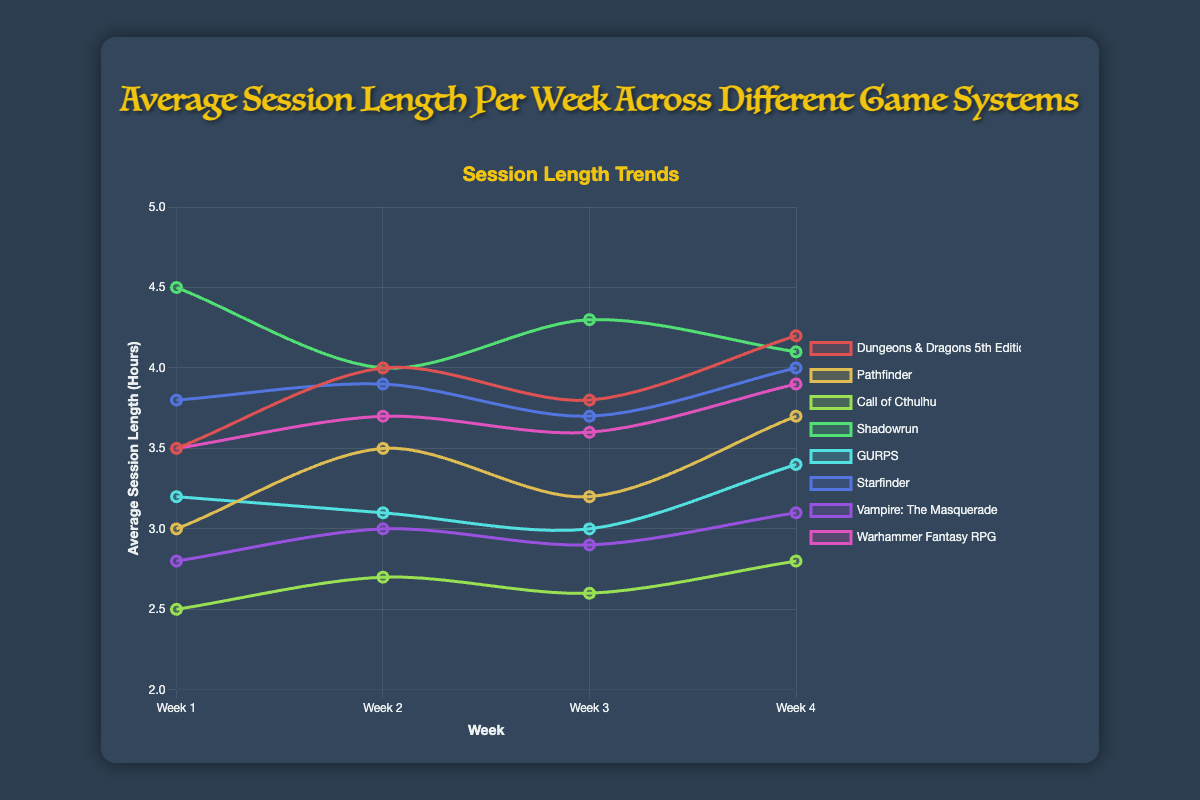What is the average session length per week for Dungeons & Dragons 5th Edition? To find the average, sum the session lengths for the four weeks and divide by 4. (3.5 + 4.0 + 3.8 + 4.2) = 15.5. Divide 15.5 by 4.
Answer: 3.875 Which game system has the highest average session length in Week 1? Compare the session lengths in Week 1 across all systems. The values are: Dungeons & Dragons 5th Edition (3.5), Pathfinder (3.0), Call of Cthulhu (2.5), Shadowrun (4.5), GURPS (3.2), Starfinder (3.8), Vampire: The Masquerade (2.8), Warhammer Fantasy RPG (3.5). Shadowrun has the highest value.
Answer: Shadowrun By how much did the session length for Shadowrun change from Week 1 to Week 4? Subtract the session length in Week 4 from that in Week 1 for Shadowrun. 4.5 (Week 1) - 4.1 (Week 4).
Answer: -0.4 Which game system shows the most consistent session lengths over the four weeks, based on visual inspection? Consistency can be assessed by checking which line is the flattest on the graph. Call of Cthulhu’s line has minor fluctuations between 2.5, 2.7, 2.6, and 2.8.
Answer: Call of Cthulhu What is the total session length for Starfinder over the four weeks? Add the session lengths for each week for Starfinder. 3.8 + 3.9 + 3.7 + 4.0.
Answer: 15.4 Which game systems increased their session lengths from Week 1 to Week 4? Dungeons & Dragons 5th Edition (3.5 to 4.2), Pathfinder (3.0 to 3.7), Call of Cthulhu (2.5 to 2.8), GURPS (3.2 to 3.4), Vampire: The Masquerade (2.8 to 3.1), Warhammer Fantasy RPG (3.5 to 3.9). Shadowrun and Starfinder decreased.
Answer: D&D 5E, Pathfinder, Call of Cthulhu, GURPS, Vampire: The Masquerade, Warhammer Fantasy RPG Which game system saw the largest drop in session length from Week 1 to Week 2? Calculate the difference for each game system between Week 1 and Week 2. Shadowrun dropped from 4.5 to 4.0 (0.5), which is the largest drop.
Answer: Shadowrun By how much did the average session length for GURPS change over the four weeks? Subtract the average session length in Week 1 from the average session length in Week 4 for GURPS. 3.2 (Week 1) - 3.4 (Week 4).
Answer: -0.2 Compare the session lengths of Dungeons & Dragons 5th Edition and Pathfinder in Week 2. Which one is longer and by how much? Compare the values for Week 2. Dungeons & Dragons 5th Edition (4.0) and Pathfinder (3.5). 4.0 - 3.5.
Answer: Dungeons & Dragons 5th Edition by 0.5 